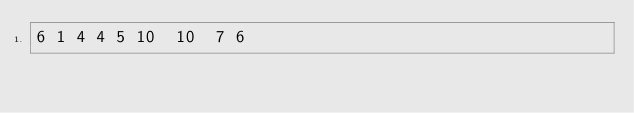Convert code to text. <code><loc_0><loc_0><loc_500><loc_500><_ObjectiveC_>6	1	4	4	5	10	10	7	6	</code> 